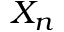Convert formula to latex. <formula><loc_0><loc_0><loc_500><loc_500>X _ { n }</formula> 